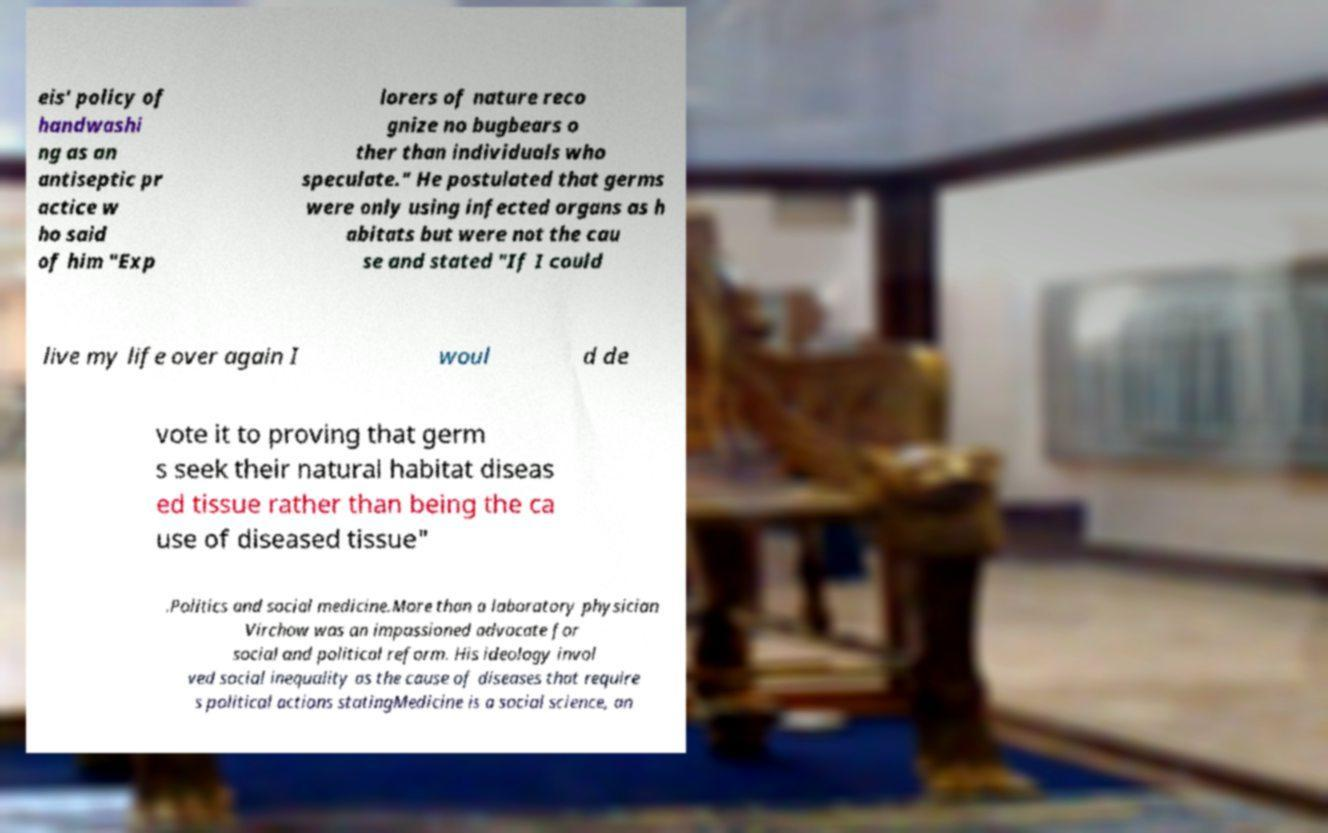What messages or text are displayed in this image? I need them in a readable, typed format. eis' policy of handwashi ng as an antiseptic pr actice w ho said of him "Exp lorers of nature reco gnize no bugbears o ther than individuals who speculate." He postulated that germs were only using infected organs as h abitats but were not the cau se and stated "If I could live my life over again I woul d de vote it to proving that germ s seek their natural habitat diseas ed tissue rather than being the ca use of diseased tissue" .Politics and social medicine.More than a laboratory physician Virchow was an impassioned advocate for social and political reform. His ideology invol ved social inequality as the cause of diseases that require s political actions statingMedicine is a social science, an 